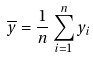<formula> <loc_0><loc_0><loc_500><loc_500>\overline { y } = \frac { 1 } { n } \sum _ { i = 1 } ^ { n } y _ { i }</formula> 